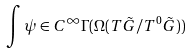<formula> <loc_0><loc_0><loc_500><loc_500>\int \psi \in C ^ { \infty } \Gamma ( \Omega ( T \tilde { G } / T ^ { 0 } \tilde { G } ) )</formula> 